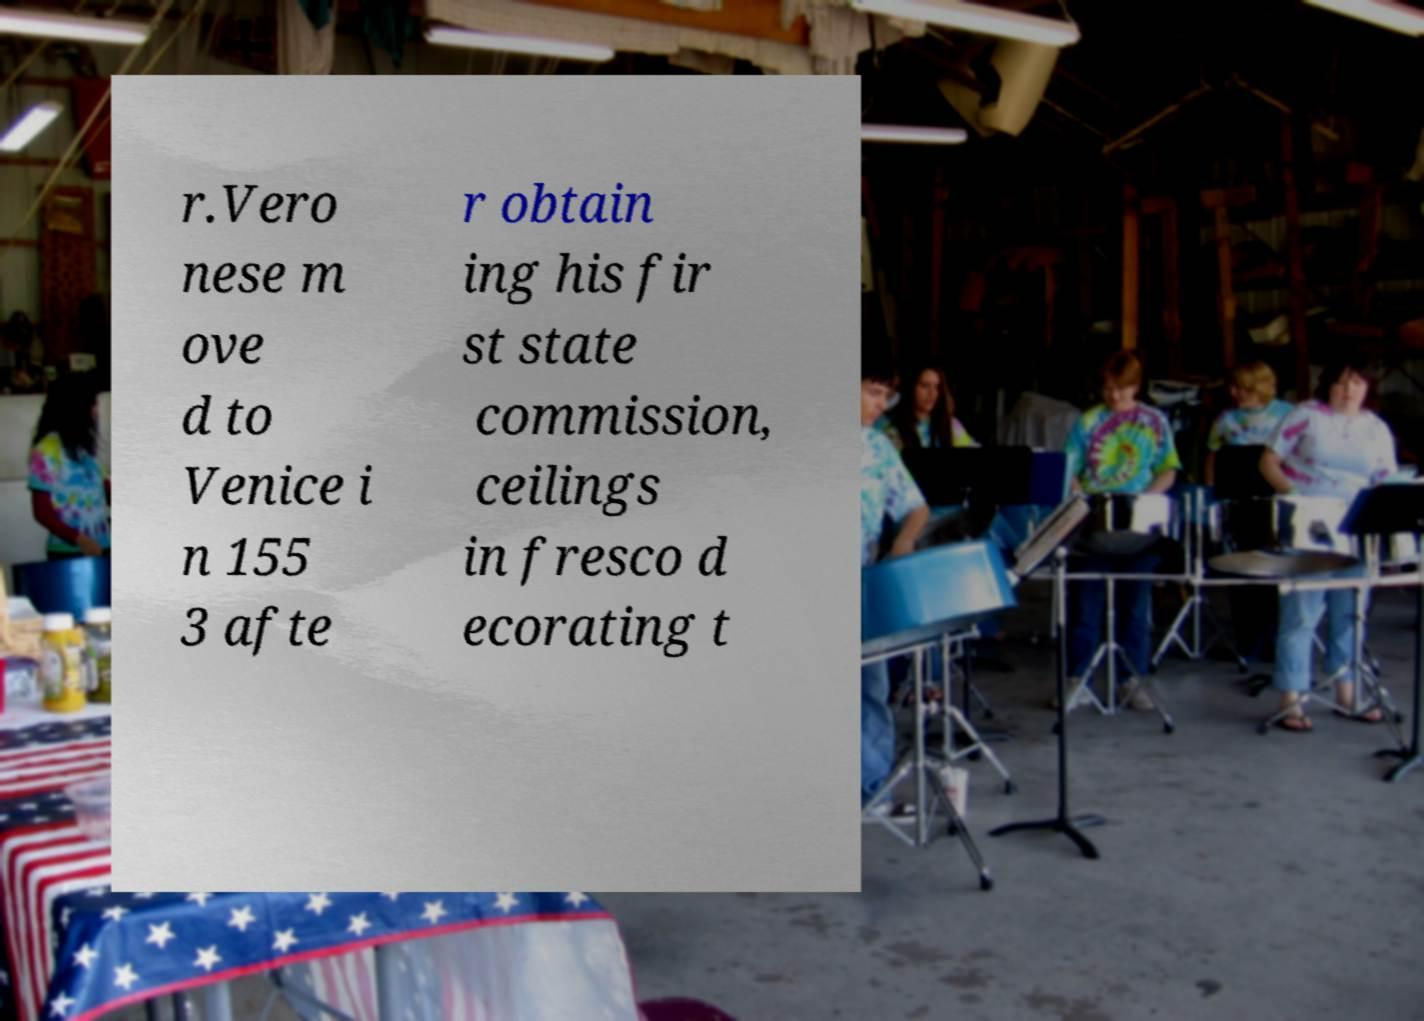Could you assist in decoding the text presented in this image and type it out clearly? r.Vero nese m ove d to Venice i n 155 3 afte r obtain ing his fir st state commission, ceilings in fresco d ecorating t 